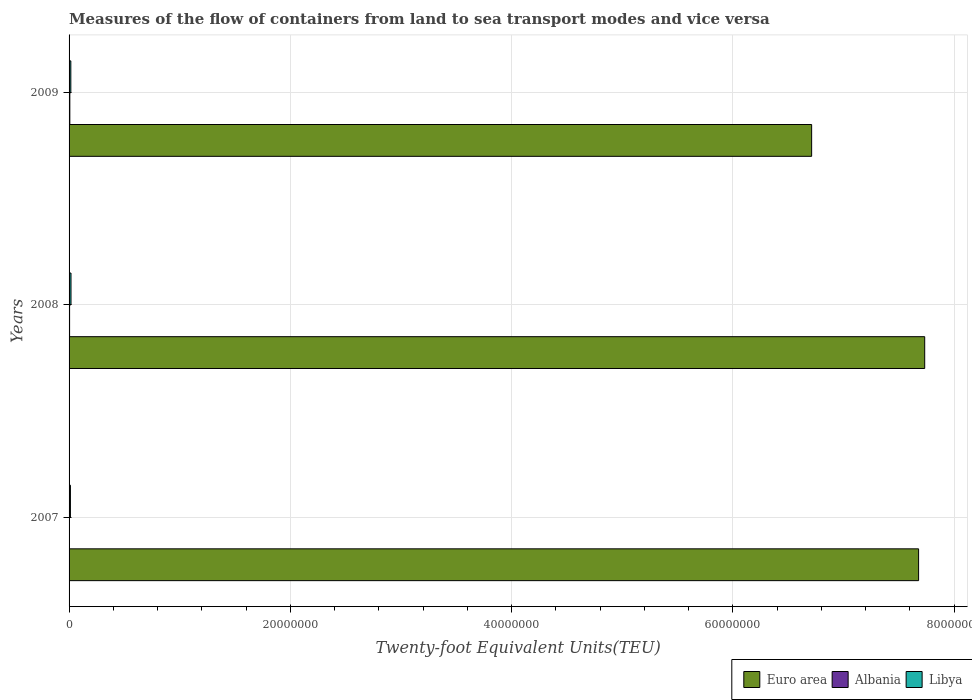Are the number of bars per tick equal to the number of legend labels?
Offer a very short reply. Yes. How many bars are there on the 2nd tick from the top?
Provide a short and direct response. 3. How many bars are there on the 2nd tick from the bottom?
Give a very brief answer. 3. What is the container port traffic in Albania in 2009?
Your response must be concise. 6.88e+04. Across all years, what is the maximum container port traffic in Libya?
Your response must be concise. 1.75e+05. Across all years, what is the minimum container port traffic in Albania?
Offer a terse response. 3.31e+04. In which year was the container port traffic in Libya maximum?
Your response must be concise. 2008. In which year was the container port traffic in Libya minimum?
Offer a very short reply. 2007. What is the total container port traffic in Albania in the graph?
Your answer should be compact. 1.49e+05. What is the difference between the container port traffic in Albania in 2007 and that in 2008?
Provide a short and direct response. -1.37e+04. What is the difference between the container port traffic in Albania in 2008 and the container port traffic in Libya in 2007?
Your response must be concise. -7.53e+04. What is the average container port traffic in Euro area per year?
Your answer should be compact. 7.37e+07. In the year 2008, what is the difference between the container port traffic in Albania and container port traffic in Euro area?
Offer a very short reply. -7.73e+07. What is the ratio of the container port traffic in Libya in 2007 to that in 2009?
Your answer should be very brief. 0.77. Is the container port traffic in Albania in 2007 less than that in 2009?
Your answer should be very brief. Yes. What is the difference between the highest and the second highest container port traffic in Albania?
Make the answer very short. 2.20e+04. What is the difference between the highest and the lowest container port traffic in Euro area?
Your answer should be very brief. 1.02e+07. What does the 2nd bar from the top in 2008 represents?
Provide a succinct answer. Albania. What does the 2nd bar from the bottom in 2008 represents?
Provide a succinct answer. Albania. What is the difference between two consecutive major ticks on the X-axis?
Provide a short and direct response. 2.00e+07. Does the graph contain grids?
Your answer should be very brief. Yes. Where does the legend appear in the graph?
Your response must be concise. Bottom right. How are the legend labels stacked?
Provide a short and direct response. Horizontal. What is the title of the graph?
Your response must be concise. Measures of the flow of containers from land to sea transport modes and vice versa. Does "South Africa" appear as one of the legend labels in the graph?
Your answer should be very brief. No. What is the label or title of the X-axis?
Provide a short and direct response. Twenty-foot Equivalent Units(TEU). What is the label or title of the Y-axis?
Provide a short and direct response. Years. What is the Twenty-foot Equivalent Units(TEU) of Euro area in 2007?
Keep it short and to the point. 7.68e+07. What is the Twenty-foot Equivalent Units(TEU) in Albania in 2007?
Make the answer very short. 3.31e+04. What is the Twenty-foot Equivalent Units(TEU) in Libya in 2007?
Your answer should be compact. 1.22e+05. What is the Twenty-foot Equivalent Units(TEU) of Euro area in 2008?
Your response must be concise. 7.73e+07. What is the Twenty-foot Equivalent Units(TEU) of Albania in 2008?
Provide a short and direct response. 4.68e+04. What is the Twenty-foot Equivalent Units(TEU) in Libya in 2008?
Offer a very short reply. 1.75e+05. What is the Twenty-foot Equivalent Units(TEU) of Euro area in 2009?
Make the answer very short. 6.71e+07. What is the Twenty-foot Equivalent Units(TEU) of Albania in 2009?
Your response must be concise. 6.88e+04. What is the Twenty-foot Equivalent Units(TEU) of Libya in 2009?
Your answer should be very brief. 1.59e+05. Across all years, what is the maximum Twenty-foot Equivalent Units(TEU) of Euro area?
Your answer should be very brief. 7.73e+07. Across all years, what is the maximum Twenty-foot Equivalent Units(TEU) of Albania?
Offer a very short reply. 6.88e+04. Across all years, what is the maximum Twenty-foot Equivalent Units(TEU) in Libya?
Your answer should be very brief. 1.75e+05. Across all years, what is the minimum Twenty-foot Equivalent Units(TEU) of Euro area?
Make the answer very short. 6.71e+07. Across all years, what is the minimum Twenty-foot Equivalent Units(TEU) in Albania?
Your answer should be very brief. 3.31e+04. Across all years, what is the minimum Twenty-foot Equivalent Units(TEU) of Libya?
Provide a short and direct response. 1.22e+05. What is the total Twenty-foot Equivalent Units(TEU) of Euro area in the graph?
Provide a short and direct response. 2.21e+08. What is the total Twenty-foot Equivalent Units(TEU) of Albania in the graph?
Provide a short and direct response. 1.49e+05. What is the total Twenty-foot Equivalent Units(TEU) of Libya in the graph?
Your answer should be very brief. 4.56e+05. What is the difference between the Twenty-foot Equivalent Units(TEU) in Euro area in 2007 and that in 2008?
Give a very brief answer. -5.53e+05. What is the difference between the Twenty-foot Equivalent Units(TEU) of Albania in 2007 and that in 2008?
Your answer should be very brief. -1.37e+04. What is the difference between the Twenty-foot Equivalent Units(TEU) of Libya in 2007 and that in 2008?
Ensure brevity in your answer.  -5.27e+04. What is the difference between the Twenty-foot Equivalent Units(TEU) of Euro area in 2007 and that in 2009?
Ensure brevity in your answer.  9.67e+06. What is the difference between the Twenty-foot Equivalent Units(TEU) in Albania in 2007 and that in 2009?
Your response must be concise. -3.57e+04. What is the difference between the Twenty-foot Equivalent Units(TEU) of Libya in 2007 and that in 2009?
Give a very brief answer. -3.69e+04. What is the difference between the Twenty-foot Equivalent Units(TEU) of Euro area in 2008 and that in 2009?
Keep it short and to the point. 1.02e+07. What is the difference between the Twenty-foot Equivalent Units(TEU) in Albania in 2008 and that in 2009?
Keep it short and to the point. -2.20e+04. What is the difference between the Twenty-foot Equivalent Units(TEU) of Libya in 2008 and that in 2009?
Give a very brief answer. 1.58e+04. What is the difference between the Twenty-foot Equivalent Units(TEU) in Euro area in 2007 and the Twenty-foot Equivalent Units(TEU) in Albania in 2008?
Give a very brief answer. 7.67e+07. What is the difference between the Twenty-foot Equivalent Units(TEU) in Euro area in 2007 and the Twenty-foot Equivalent Units(TEU) in Libya in 2008?
Give a very brief answer. 7.66e+07. What is the difference between the Twenty-foot Equivalent Units(TEU) in Albania in 2007 and the Twenty-foot Equivalent Units(TEU) in Libya in 2008?
Give a very brief answer. -1.42e+05. What is the difference between the Twenty-foot Equivalent Units(TEU) of Euro area in 2007 and the Twenty-foot Equivalent Units(TEU) of Albania in 2009?
Your answer should be compact. 7.67e+07. What is the difference between the Twenty-foot Equivalent Units(TEU) in Euro area in 2007 and the Twenty-foot Equivalent Units(TEU) in Libya in 2009?
Provide a short and direct response. 7.66e+07. What is the difference between the Twenty-foot Equivalent Units(TEU) in Albania in 2007 and the Twenty-foot Equivalent Units(TEU) in Libya in 2009?
Give a very brief answer. -1.26e+05. What is the difference between the Twenty-foot Equivalent Units(TEU) of Euro area in 2008 and the Twenty-foot Equivalent Units(TEU) of Albania in 2009?
Your response must be concise. 7.73e+07. What is the difference between the Twenty-foot Equivalent Units(TEU) in Euro area in 2008 and the Twenty-foot Equivalent Units(TEU) in Libya in 2009?
Offer a terse response. 7.72e+07. What is the difference between the Twenty-foot Equivalent Units(TEU) in Albania in 2008 and the Twenty-foot Equivalent Units(TEU) in Libya in 2009?
Your response must be concise. -1.12e+05. What is the average Twenty-foot Equivalent Units(TEU) of Euro area per year?
Your response must be concise. 7.37e+07. What is the average Twenty-foot Equivalent Units(TEU) in Albania per year?
Offer a very short reply. 4.96e+04. What is the average Twenty-foot Equivalent Units(TEU) of Libya per year?
Make the answer very short. 1.52e+05. In the year 2007, what is the difference between the Twenty-foot Equivalent Units(TEU) of Euro area and Twenty-foot Equivalent Units(TEU) of Albania?
Provide a short and direct response. 7.67e+07. In the year 2007, what is the difference between the Twenty-foot Equivalent Units(TEU) in Euro area and Twenty-foot Equivalent Units(TEU) in Libya?
Provide a succinct answer. 7.67e+07. In the year 2007, what is the difference between the Twenty-foot Equivalent Units(TEU) of Albania and Twenty-foot Equivalent Units(TEU) of Libya?
Provide a short and direct response. -8.90e+04. In the year 2008, what is the difference between the Twenty-foot Equivalent Units(TEU) of Euro area and Twenty-foot Equivalent Units(TEU) of Albania?
Ensure brevity in your answer.  7.73e+07. In the year 2008, what is the difference between the Twenty-foot Equivalent Units(TEU) in Euro area and Twenty-foot Equivalent Units(TEU) in Libya?
Provide a succinct answer. 7.72e+07. In the year 2008, what is the difference between the Twenty-foot Equivalent Units(TEU) in Albania and Twenty-foot Equivalent Units(TEU) in Libya?
Ensure brevity in your answer.  -1.28e+05. In the year 2009, what is the difference between the Twenty-foot Equivalent Units(TEU) in Euro area and Twenty-foot Equivalent Units(TEU) in Albania?
Provide a short and direct response. 6.70e+07. In the year 2009, what is the difference between the Twenty-foot Equivalent Units(TEU) in Euro area and Twenty-foot Equivalent Units(TEU) in Libya?
Offer a terse response. 6.70e+07. In the year 2009, what is the difference between the Twenty-foot Equivalent Units(TEU) of Albania and Twenty-foot Equivalent Units(TEU) of Libya?
Your response must be concise. -9.02e+04. What is the ratio of the Twenty-foot Equivalent Units(TEU) of Euro area in 2007 to that in 2008?
Offer a terse response. 0.99. What is the ratio of the Twenty-foot Equivalent Units(TEU) of Albania in 2007 to that in 2008?
Provide a succinct answer. 0.71. What is the ratio of the Twenty-foot Equivalent Units(TEU) of Libya in 2007 to that in 2008?
Give a very brief answer. 0.7. What is the ratio of the Twenty-foot Equivalent Units(TEU) of Euro area in 2007 to that in 2009?
Make the answer very short. 1.14. What is the ratio of the Twenty-foot Equivalent Units(TEU) in Albania in 2007 to that in 2009?
Provide a succinct answer. 0.48. What is the ratio of the Twenty-foot Equivalent Units(TEU) of Libya in 2007 to that in 2009?
Offer a very short reply. 0.77. What is the ratio of the Twenty-foot Equivalent Units(TEU) of Euro area in 2008 to that in 2009?
Keep it short and to the point. 1.15. What is the ratio of the Twenty-foot Equivalent Units(TEU) in Albania in 2008 to that in 2009?
Your answer should be very brief. 0.68. What is the ratio of the Twenty-foot Equivalent Units(TEU) of Libya in 2008 to that in 2009?
Provide a short and direct response. 1.1. What is the difference between the highest and the second highest Twenty-foot Equivalent Units(TEU) in Euro area?
Offer a terse response. 5.53e+05. What is the difference between the highest and the second highest Twenty-foot Equivalent Units(TEU) in Albania?
Provide a short and direct response. 2.20e+04. What is the difference between the highest and the second highest Twenty-foot Equivalent Units(TEU) in Libya?
Your answer should be very brief. 1.58e+04. What is the difference between the highest and the lowest Twenty-foot Equivalent Units(TEU) of Euro area?
Give a very brief answer. 1.02e+07. What is the difference between the highest and the lowest Twenty-foot Equivalent Units(TEU) of Albania?
Your answer should be very brief. 3.57e+04. What is the difference between the highest and the lowest Twenty-foot Equivalent Units(TEU) in Libya?
Your answer should be compact. 5.27e+04. 